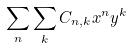Convert formula to latex. <formula><loc_0><loc_0><loc_500><loc_500>\sum _ { n } \sum _ { k } C _ { n , k } x ^ { n } y ^ { k }</formula> 